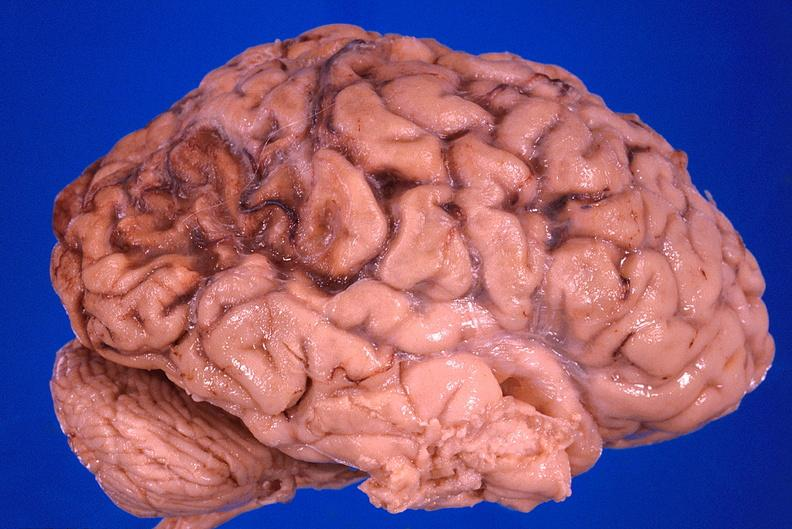what does this image show?
Answer the question using a single word or phrase. Brain 